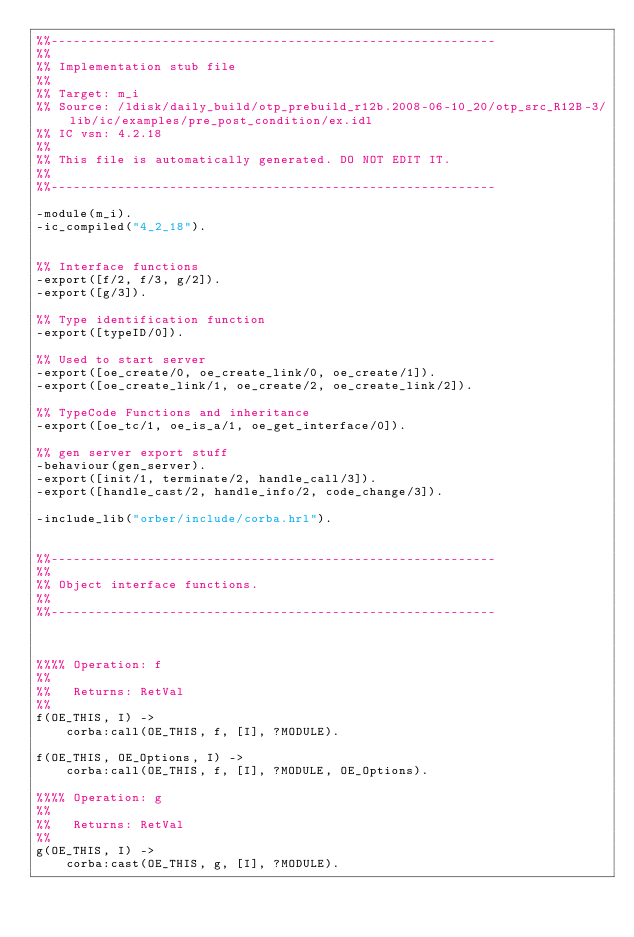<code> <loc_0><loc_0><loc_500><loc_500><_Erlang_>%%------------------------------------------------------------
%%
%% Implementation stub file
%% 
%% Target: m_i
%% Source: /ldisk/daily_build/otp_prebuild_r12b.2008-06-10_20/otp_src_R12B-3/lib/ic/examples/pre_post_condition/ex.idl
%% IC vsn: 4.2.18
%% 
%% This file is automatically generated. DO NOT EDIT IT.
%%
%%------------------------------------------------------------

-module(m_i).
-ic_compiled("4_2_18").


%% Interface functions
-export([f/2, f/3, g/2]).
-export([g/3]).

%% Type identification function
-export([typeID/0]).

%% Used to start server
-export([oe_create/0, oe_create_link/0, oe_create/1]).
-export([oe_create_link/1, oe_create/2, oe_create_link/2]).

%% TypeCode Functions and inheritance
-export([oe_tc/1, oe_is_a/1, oe_get_interface/0]).

%% gen server export stuff
-behaviour(gen_server).
-export([init/1, terminate/2, handle_call/3]).
-export([handle_cast/2, handle_info/2, code_change/3]).

-include_lib("orber/include/corba.hrl").


%%------------------------------------------------------------
%%
%% Object interface functions.
%%
%%------------------------------------------------------------



%%%% Operation: f
%% 
%%   Returns: RetVal
%%
f(OE_THIS, I) ->
    corba:call(OE_THIS, f, [I], ?MODULE).

f(OE_THIS, OE_Options, I) ->
    corba:call(OE_THIS, f, [I], ?MODULE, OE_Options).

%%%% Operation: g
%% 
%%   Returns: RetVal
%%
g(OE_THIS, I) ->
    corba:cast(OE_THIS, g, [I], ?MODULE).
</code> 